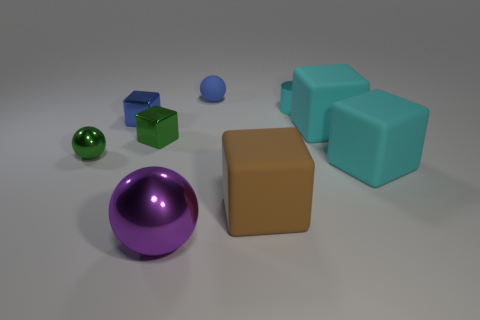Subtract all matte blocks. How many blocks are left? 2 Subtract all cyan blocks. How many blocks are left? 3 Subtract all blue cylinders. How many cyan cubes are left? 2 Subtract all cubes. How many objects are left? 4 Subtract 4 cubes. How many cubes are left? 1 Subtract 0 yellow spheres. How many objects are left? 9 Subtract all yellow cylinders. Subtract all gray balls. How many cylinders are left? 1 Subtract all tiny green shiny things. Subtract all tiny blue metallic objects. How many objects are left? 6 Add 7 tiny matte spheres. How many tiny matte spheres are left? 8 Add 5 large cyan blocks. How many large cyan blocks exist? 7 